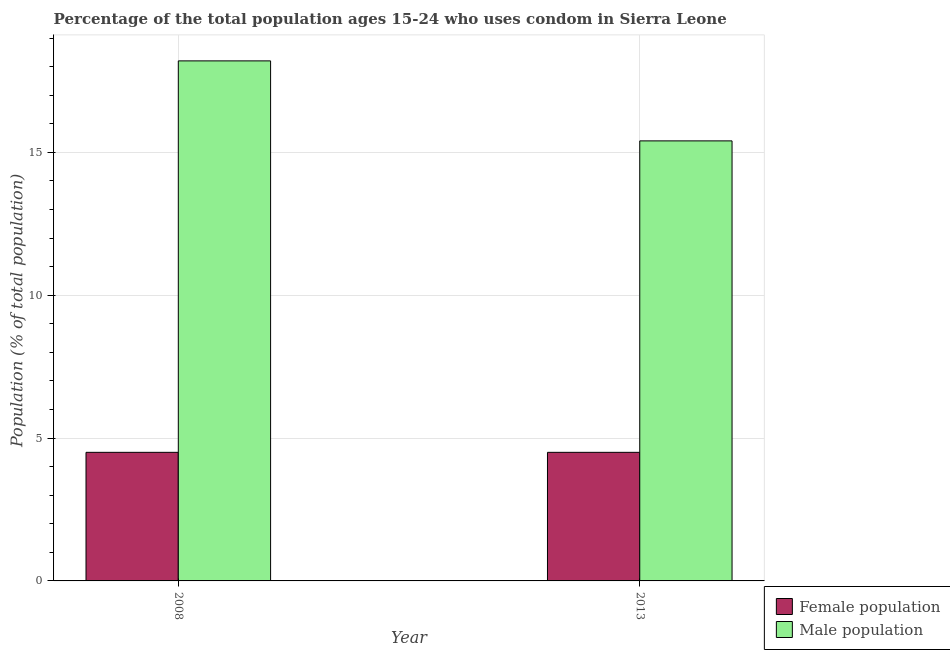How many different coloured bars are there?
Your answer should be very brief. 2. How many groups of bars are there?
Your response must be concise. 2. Are the number of bars on each tick of the X-axis equal?
Make the answer very short. Yes. How many bars are there on the 2nd tick from the right?
Ensure brevity in your answer.  2. What is the male population in 2013?
Keep it short and to the point. 15.4. Across all years, what is the maximum male population?
Ensure brevity in your answer.  18.2. In which year was the male population maximum?
Your response must be concise. 2008. What is the total male population in the graph?
Offer a terse response. 33.6. What is the difference between the female population in 2008 and the male population in 2013?
Your answer should be very brief. 0. What does the 1st bar from the left in 2013 represents?
Keep it short and to the point. Female population. What does the 2nd bar from the right in 2013 represents?
Offer a very short reply. Female population. How many bars are there?
Your response must be concise. 4. How many years are there in the graph?
Keep it short and to the point. 2. What is the difference between two consecutive major ticks on the Y-axis?
Your answer should be compact. 5. Where does the legend appear in the graph?
Provide a succinct answer. Bottom right. How many legend labels are there?
Keep it short and to the point. 2. What is the title of the graph?
Your answer should be compact. Percentage of the total population ages 15-24 who uses condom in Sierra Leone. What is the label or title of the X-axis?
Offer a terse response. Year. What is the label or title of the Y-axis?
Your answer should be very brief. Population (% of total population) . What is the Population (% of total population)  of Female population in 2013?
Offer a very short reply. 4.5. What is the Population (% of total population)  of Male population in 2013?
Give a very brief answer. 15.4. Across all years, what is the minimum Population (% of total population)  of Male population?
Offer a very short reply. 15.4. What is the total Population (% of total population)  in Male population in the graph?
Offer a terse response. 33.6. What is the difference between the Population (% of total population)  in Female population in 2008 and that in 2013?
Provide a short and direct response. 0. What is the difference between the Population (% of total population)  of Male population in 2008 and that in 2013?
Give a very brief answer. 2.8. What is the average Population (% of total population)  of Female population per year?
Provide a succinct answer. 4.5. In the year 2008, what is the difference between the Population (% of total population)  of Female population and Population (% of total population)  of Male population?
Offer a very short reply. -13.7. What is the ratio of the Population (% of total population)  in Female population in 2008 to that in 2013?
Offer a very short reply. 1. What is the ratio of the Population (% of total population)  in Male population in 2008 to that in 2013?
Give a very brief answer. 1.18. What is the difference between the highest and the second highest Population (% of total population)  in Female population?
Your answer should be very brief. 0. What is the difference between the highest and the second highest Population (% of total population)  of Male population?
Provide a succinct answer. 2.8. What is the difference between the highest and the lowest Population (% of total population)  in Female population?
Your answer should be compact. 0. 